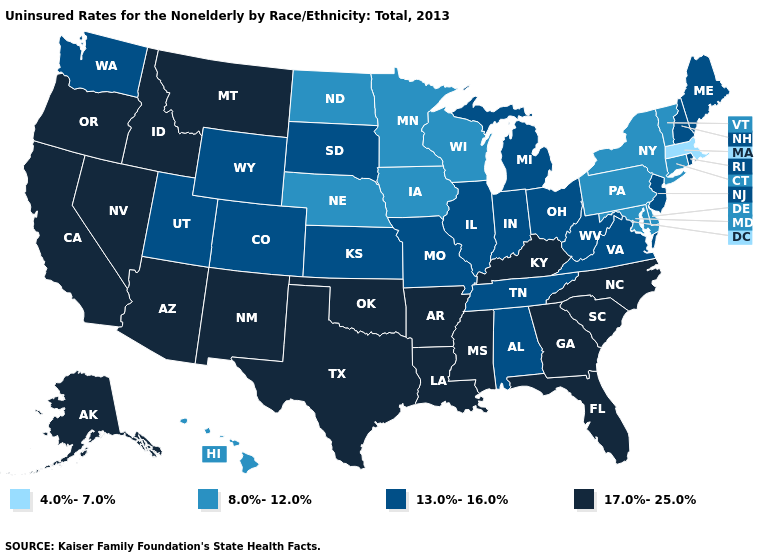Among the states that border Pennsylvania , which have the lowest value?
Keep it brief. Delaware, Maryland, New York. Does Alaska have the lowest value in the West?
Write a very short answer. No. What is the lowest value in states that border Ohio?
Give a very brief answer. 8.0%-12.0%. What is the lowest value in the USA?
Keep it brief. 4.0%-7.0%. What is the value of California?
Short answer required. 17.0%-25.0%. What is the lowest value in states that border Virginia?
Quick response, please. 8.0%-12.0%. Name the states that have a value in the range 4.0%-7.0%?
Give a very brief answer. Massachusetts. Which states have the highest value in the USA?
Concise answer only. Alaska, Arizona, Arkansas, California, Florida, Georgia, Idaho, Kentucky, Louisiana, Mississippi, Montana, Nevada, New Mexico, North Carolina, Oklahoma, Oregon, South Carolina, Texas. Name the states that have a value in the range 13.0%-16.0%?
Answer briefly. Alabama, Colorado, Illinois, Indiana, Kansas, Maine, Michigan, Missouri, New Hampshire, New Jersey, Ohio, Rhode Island, South Dakota, Tennessee, Utah, Virginia, Washington, West Virginia, Wyoming. What is the value of California?
Quick response, please. 17.0%-25.0%. Does Mississippi have a higher value than Oregon?
Write a very short answer. No. What is the value of Florida?
Quick response, please. 17.0%-25.0%. Does Nebraska have the highest value in the MidWest?
Write a very short answer. No. Which states hav the highest value in the West?
Keep it brief. Alaska, Arizona, California, Idaho, Montana, Nevada, New Mexico, Oregon. Does the map have missing data?
Write a very short answer. No. 